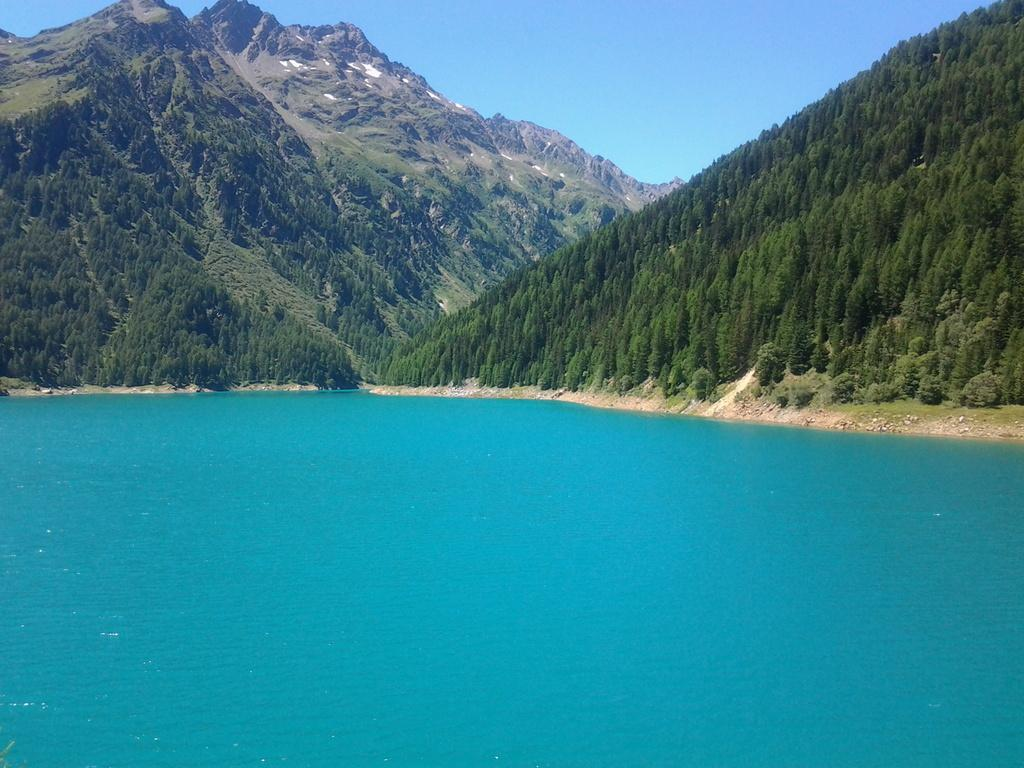What is the color of the sea in the image? The sea in the image is blue. What type of vegetation can be seen in the image? Green trees are present in the image. What type of geographical feature is visible in the image? Mountains are visible in the image. What is the color of the sky in the image? The sky is blue in the image. Can you tell me how many sheets are hanging on the line in the image? There are no sheets or lines present in the image; it features a blue sea, green trees, mountains, and a blue sky. 